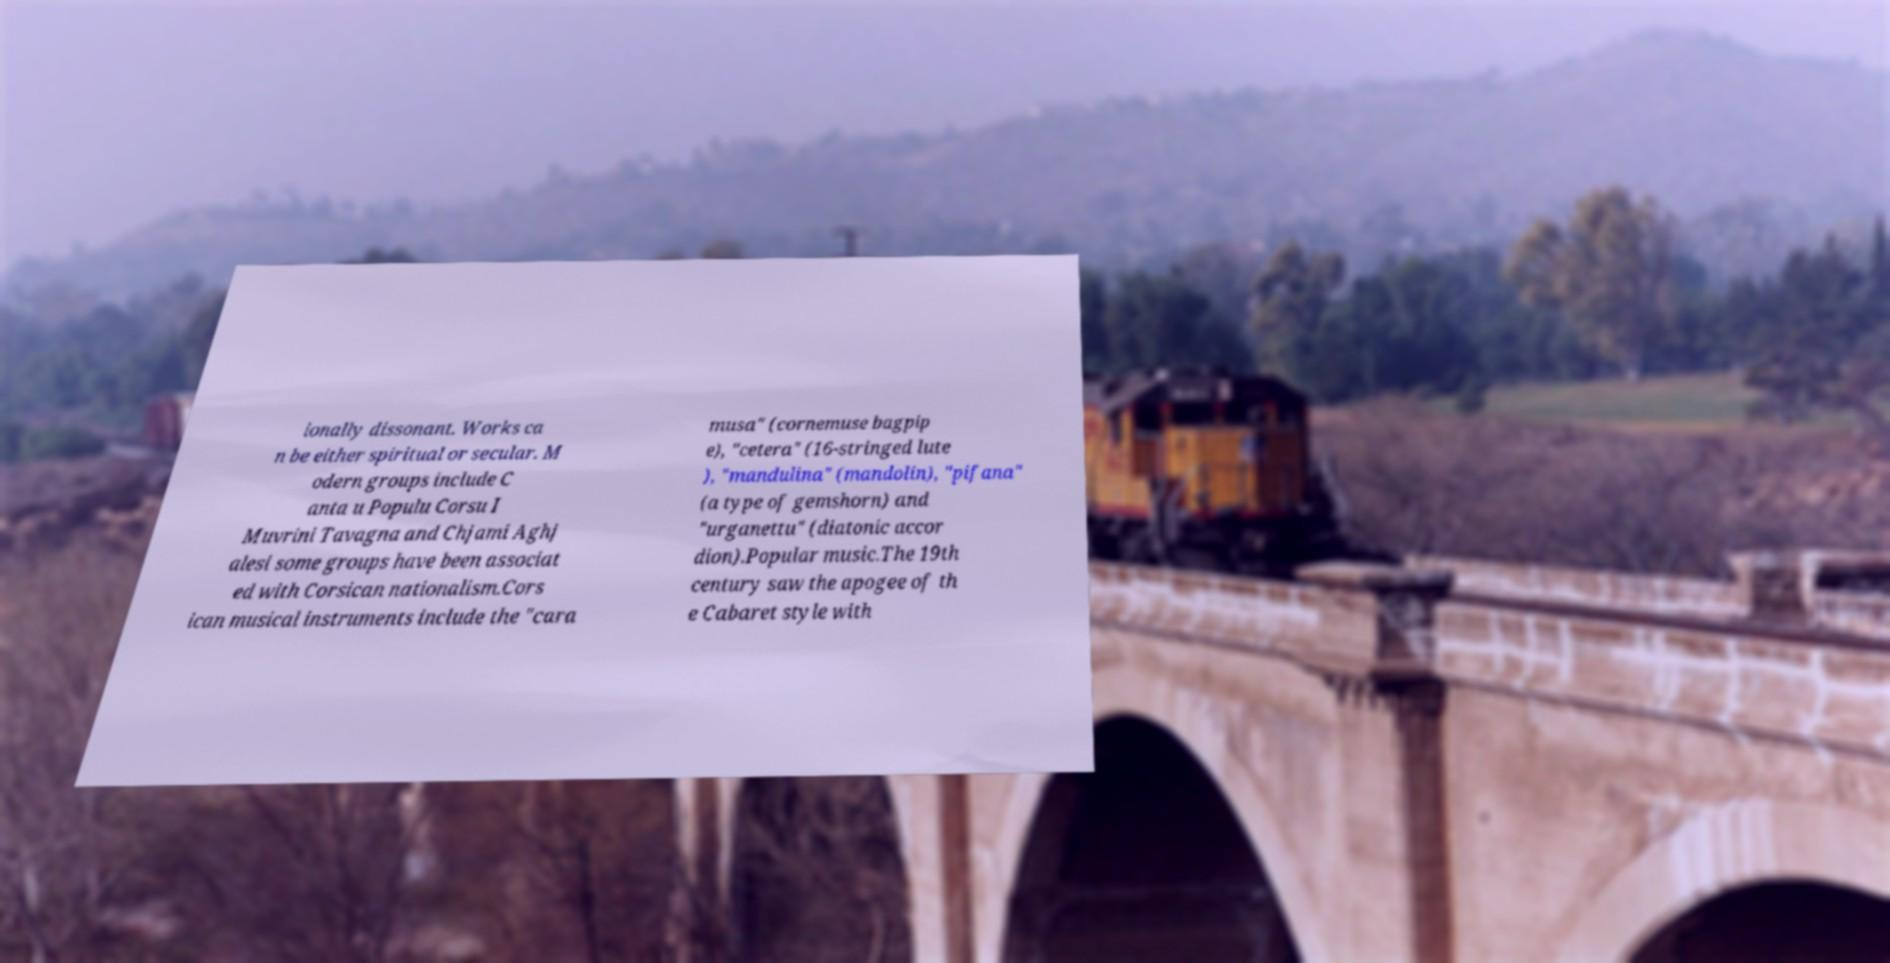Can you read and provide the text displayed in the image?This photo seems to have some interesting text. Can you extract and type it out for me? ionally dissonant. Works ca n be either spiritual or secular. M odern groups include C anta u Populu Corsu I Muvrini Tavagna and Chjami Aghj alesi some groups have been associat ed with Corsican nationalism.Cors ican musical instruments include the "cara musa" (cornemuse bagpip e), "cetera" (16-stringed lute ), "mandulina" (mandolin), "pifana" (a type of gemshorn) and "urganettu" (diatonic accor dion).Popular music.The 19th century saw the apogee of th e Cabaret style with 